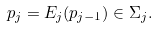<formula> <loc_0><loc_0><loc_500><loc_500>p _ { j } = E _ { j } ( p _ { j - 1 } ) \in \Sigma _ { j } .</formula> 